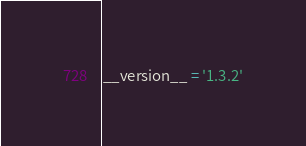Convert code to text. <code><loc_0><loc_0><loc_500><loc_500><_Python_>
__version__ = '1.3.2'</code> 